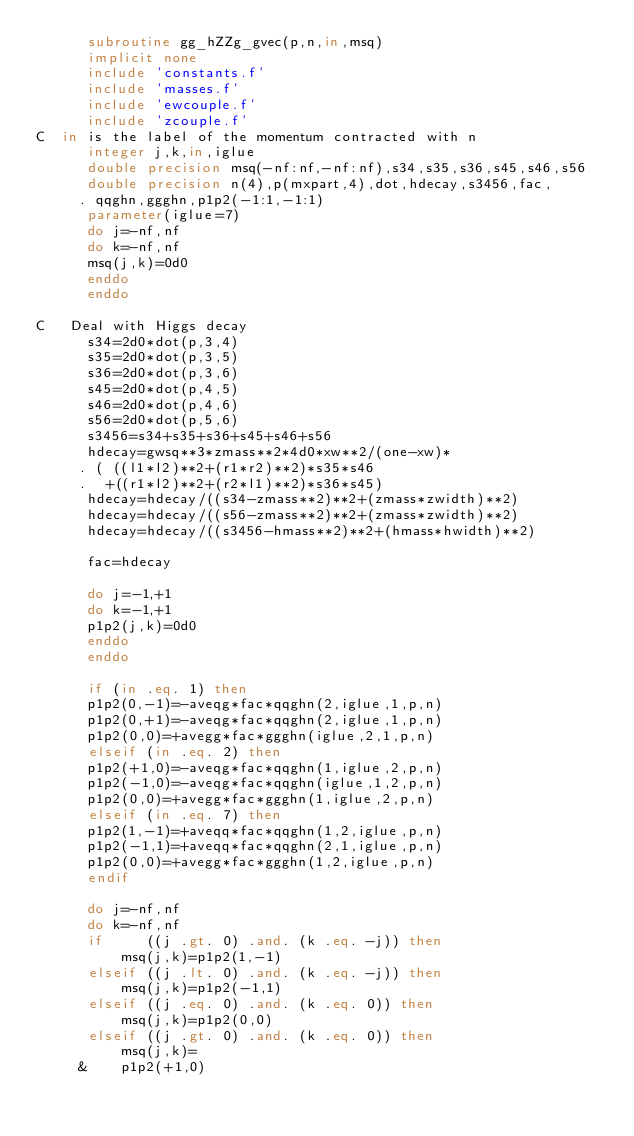<code> <loc_0><loc_0><loc_500><loc_500><_FORTRAN_>      subroutine gg_hZZg_gvec(p,n,in,msq)
      implicit none
      include 'constants.f'
      include 'masses.f'
      include 'ewcouple.f'
      include 'zcouple.f'
C  in is the label of the momentum contracted with n
      integer j,k,in,iglue
      double precision msq(-nf:nf,-nf:nf),s34,s35,s36,s45,s46,s56
      double precision n(4),p(mxpart,4),dot,hdecay,s3456,fac,
     . qqghn,ggghn,p1p2(-1:1,-1:1)
      parameter(iglue=7)
      do j=-nf,nf
      do k=-nf,nf
      msq(j,k)=0d0
      enddo
      enddo

C   Deal with Higgs decay
      s34=2d0*dot(p,3,4)
      s35=2d0*dot(p,3,5)
      s36=2d0*dot(p,3,6)
      s45=2d0*dot(p,4,5)
      s46=2d0*dot(p,4,6)
      s56=2d0*dot(p,5,6)
      s3456=s34+s35+s36+s45+s46+s56
      hdecay=gwsq**3*zmass**2*4d0*xw**2/(one-xw)*
     . ( ((l1*l2)**2+(r1*r2)**2)*s35*s46
     .  +((r1*l2)**2+(r2*l1)**2)*s36*s45)
      hdecay=hdecay/((s34-zmass**2)**2+(zmass*zwidth)**2)
      hdecay=hdecay/((s56-zmass**2)**2+(zmass*zwidth)**2)
      hdecay=hdecay/((s3456-hmass**2)**2+(hmass*hwidth)**2)

      fac=hdecay

      do j=-1,+1
      do k=-1,+1
      p1p2(j,k)=0d0
      enddo
      enddo

      if (in .eq. 1) then
      p1p2(0,-1)=-aveqg*fac*qqghn(2,iglue,1,p,n)
      p1p2(0,+1)=-aveqg*fac*qqghn(2,iglue,1,p,n)
      p1p2(0,0)=+avegg*fac*ggghn(iglue,2,1,p,n)
      elseif (in .eq. 2) then
      p1p2(+1,0)=-aveqg*fac*qqghn(1,iglue,2,p,n)
      p1p2(-1,0)=-aveqg*fac*qqghn(iglue,1,2,p,n)
      p1p2(0,0)=+avegg*fac*ggghn(1,iglue,2,p,n)
      elseif (in .eq. 7) then
      p1p2(1,-1)=+aveqq*fac*qqghn(1,2,iglue,p,n)
      p1p2(-1,1)=+aveqq*fac*qqghn(2,1,iglue,p,n)
      p1p2(0,0)=+avegg*fac*ggghn(1,2,iglue,p,n)
      endif

      do j=-nf,nf
      do k=-nf,nf
      if     ((j .gt. 0) .and. (k .eq. -j)) then
          msq(j,k)=p1p2(1,-1)
      elseif ((j .lt. 0) .and. (k .eq. -j)) then
          msq(j,k)=p1p2(-1,1)
      elseif ((j .eq. 0) .and. (k .eq. 0)) then
          msq(j,k)=p1p2(0,0)
      elseif ((j .gt. 0) .and. (k .eq. 0)) then
          msq(j,k)=
     &    p1p2(+1,0)</code> 